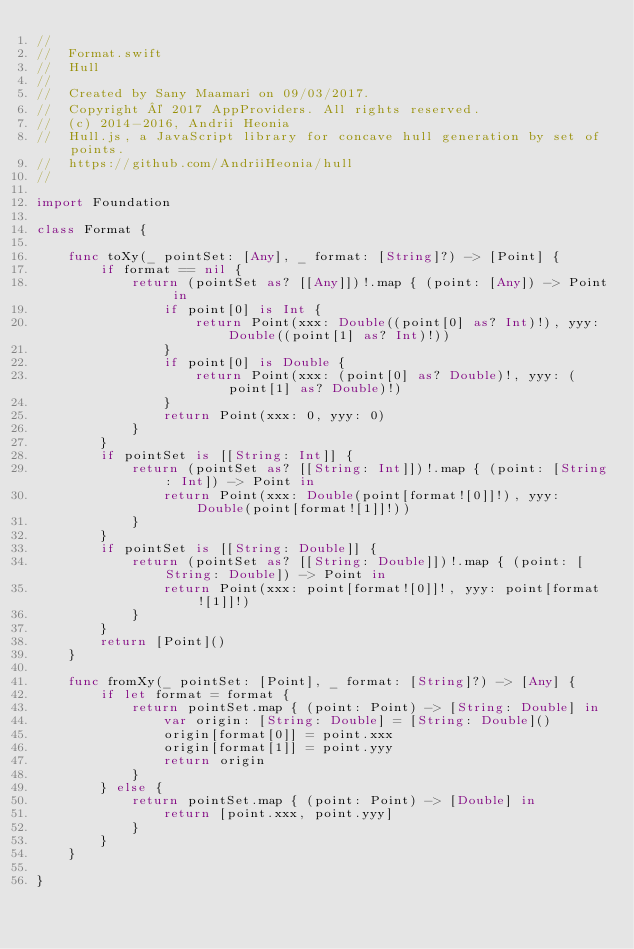Convert code to text. <code><loc_0><loc_0><loc_500><loc_500><_Swift_>//
//  Format.swift
//  Hull
//
//  Created by Sany Maamari on 09/03/2017.
//  Copyright © 2017 AppProviders. All rights reserved.
//  (c) 2014-2016, Andrii Heonia
//  Hull.js, a JavaScript library for concave hull generation by set of points.
//  https://github.com/AndriiHeonia/hull
//

import Foundation

class Format {

    func toXy(_ pointSet: [Any], _ format: [String]?) -> [Point] {
        if format == nil {
            return (pointSet as? [[Any]])!.map { (point: [Any]) -> Point in
                if point[0] is Int {
                    return Point(xxx: Double((point[0] as? Int)!), yyy: Double((point[1] as? Int)!))
                }
                if point[0] is Double {
                    return Point(xxx: (point[0] as? Double)!, yyy: (point[1] as? Double)!)
                }
                return Point(xxx: 0, yyy: 0)
            }
        }
        if pointSet is [[String: Int]] {
            return (pointSet as? [[String: Int]])!.map { (point: [String: Int]) -> Point in
                return Point(xxx: Double(point[format![0]]!), yyy: Double(point[format![1]]!))
            }
        }
        if pointSet is [[String: Double]] {
            return (pointSet as? [[String: Double]])!.map { (point: [String: Double]) -> Point in
                return Point(xxx: point[format![0]]!, yyy: point[format![1]]!)
            }
        }
        return [Point]()
    }

    func fromXy(_ pointSet: [Point], _ format: [String]?) -> [Any] {
        if let format = format {
            return pointSet.map { (point: Point) -> [String: Double] in
                var origin: [String: Double] = [String: Double]()
                origin[format[0]] = point.xxx
                origin[format[1]] = point.yyy
                return origin
            }
        } else {
            return pointSet.map { (point: Point) -> [Double] in
                return [point.xxx, point.yyy]
            }
        }
    }

}
</code> 